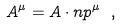<formula> <loc_0><loc_0><loc_500><loc_500>A ^ { \mu } = A \cdot n p ^ { \mu } \ ,</formula> 